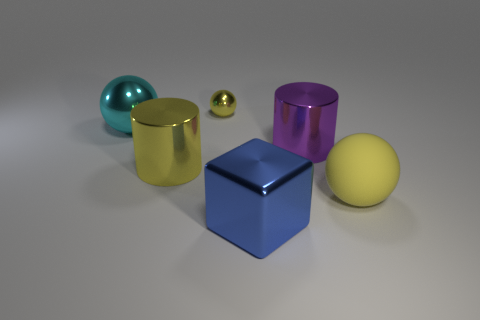Subtract all yellow balls. How many were subtracted if there are1yellow balls left? 1 Add 4 cyan metallic objects. How many objects exist? 10 Subtract all blocks. How many objects are left? 5 Subtract all big green matte spheres. Subtract all tiny yellow objects. How many objects are left? 5 Add 3 tiny yellow metal spheres. How many tiny yellow metal spheres are left? 4 Add 3 cyan shiny balls. How many cyan shiny balls exist? 4 Subtract 0 blue balls. How many objects are left? 6 